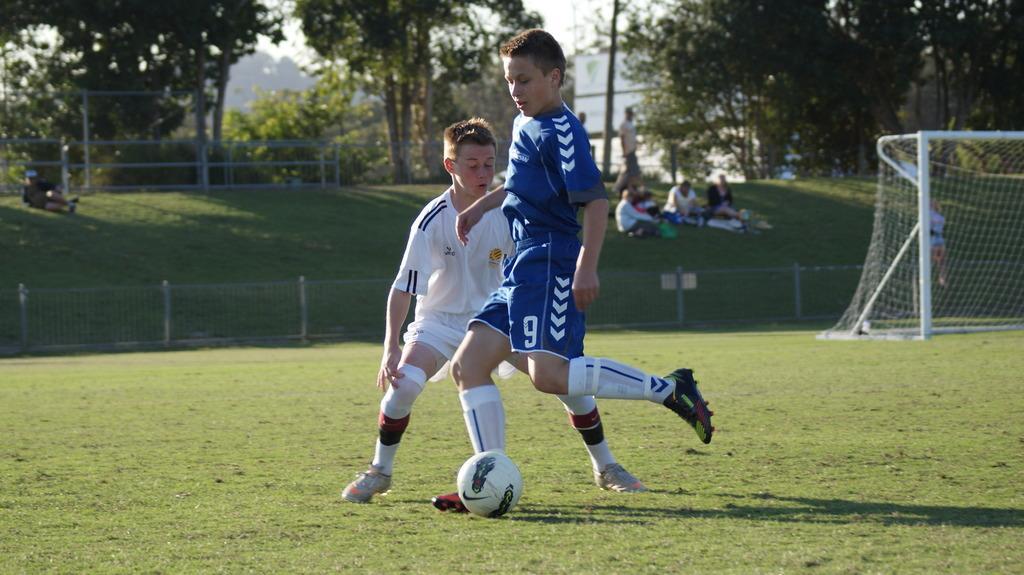Can you describe this image briefly? In this picture we can see two people playing football on the ground. Some grass is visible on the ground. There is a net on the right side. Few people and trees are visible in the background. 